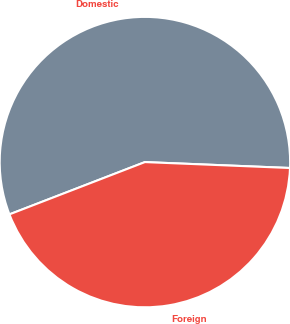Convert chart. <chart><loc_0><loc_0><loc_500><loc_500><pie_chart><fcel>Domestic<fcel>Foreign<nl><fcel>56.51%<fcel>43.49%<nl></chart> 